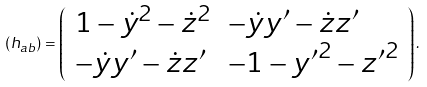<formula> <loc_0><loc_0><loc_500><loc_500>( h _ { a b } ) = \left ( \begin{array} { l l } { { 1 - \dot { y } ^ { 2 } - \dot { z } ^ { 2 } } } & { { - \dot { y } y ^ { \prime } - \dot { z } z ^ { \prime } } } \\ { { - \dot { y } y ^ { \prime } - \dot { z } z ^ { \prime } } } & { { - 1 - { y ^ { \prime } } ^ { 2 } - { z ^ { \prime } } ^ { 2 } } } \end{array} \right ) .</formula> 